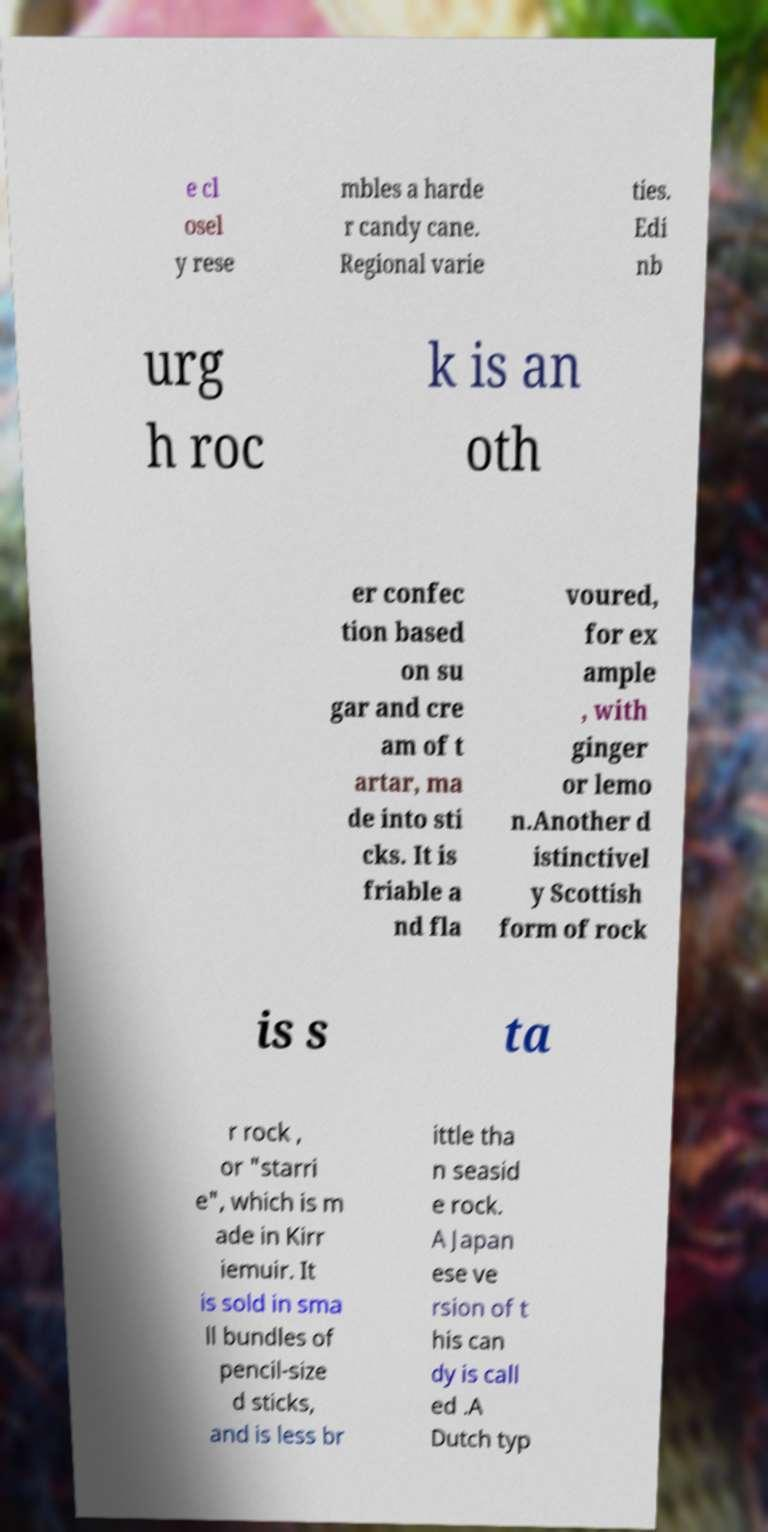Please identify and transcribe the text found in this image. e cl osel y rese mbles a harde r candy cane. Regional varie ties. Edi nb urg h roc k is an oth er confec tion based on su gar and cre am of t artar, ma de into sti cks. It is friable a nd fla voured, for ex ample , with ginger or lemo n.Another d istinctivel y Scottish form of rock is s ta r rock , or "starri e", which is m ade in Kirr iemuir. It is sold in sma ll bundles of pencil-size d sticks, and is less br ittle tha n seasid e rock. A Japan ese ve rsion of t his can dy is call ed .A Dutch typ 